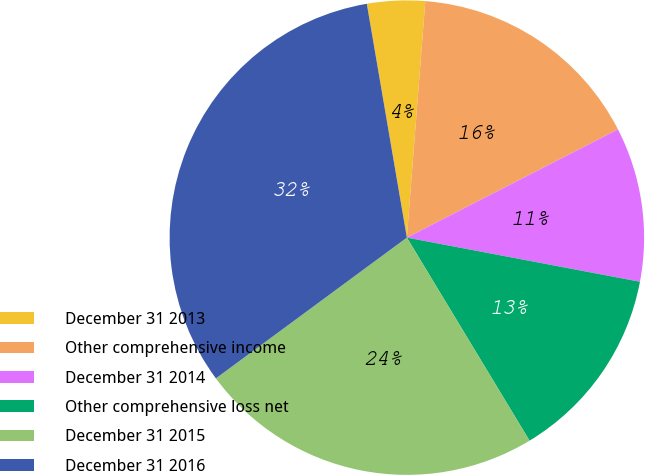Convert chart to OTSL. <chart><loc_0><loc_0><loc_500><loc_500><pie_chart><fcel>December 31 2013<fcel>Other comprehensive income<fcel>December 31 2014<fcel>Other comprehensive loss net<fcel>December 31 2015<fcel>December 31 2016<nl><fcel>3.94%<fcel>16.22%<fcel>10.52%<fcel>13.37%<fcel>23.54%<fcel>32.41%<nl></chart> 